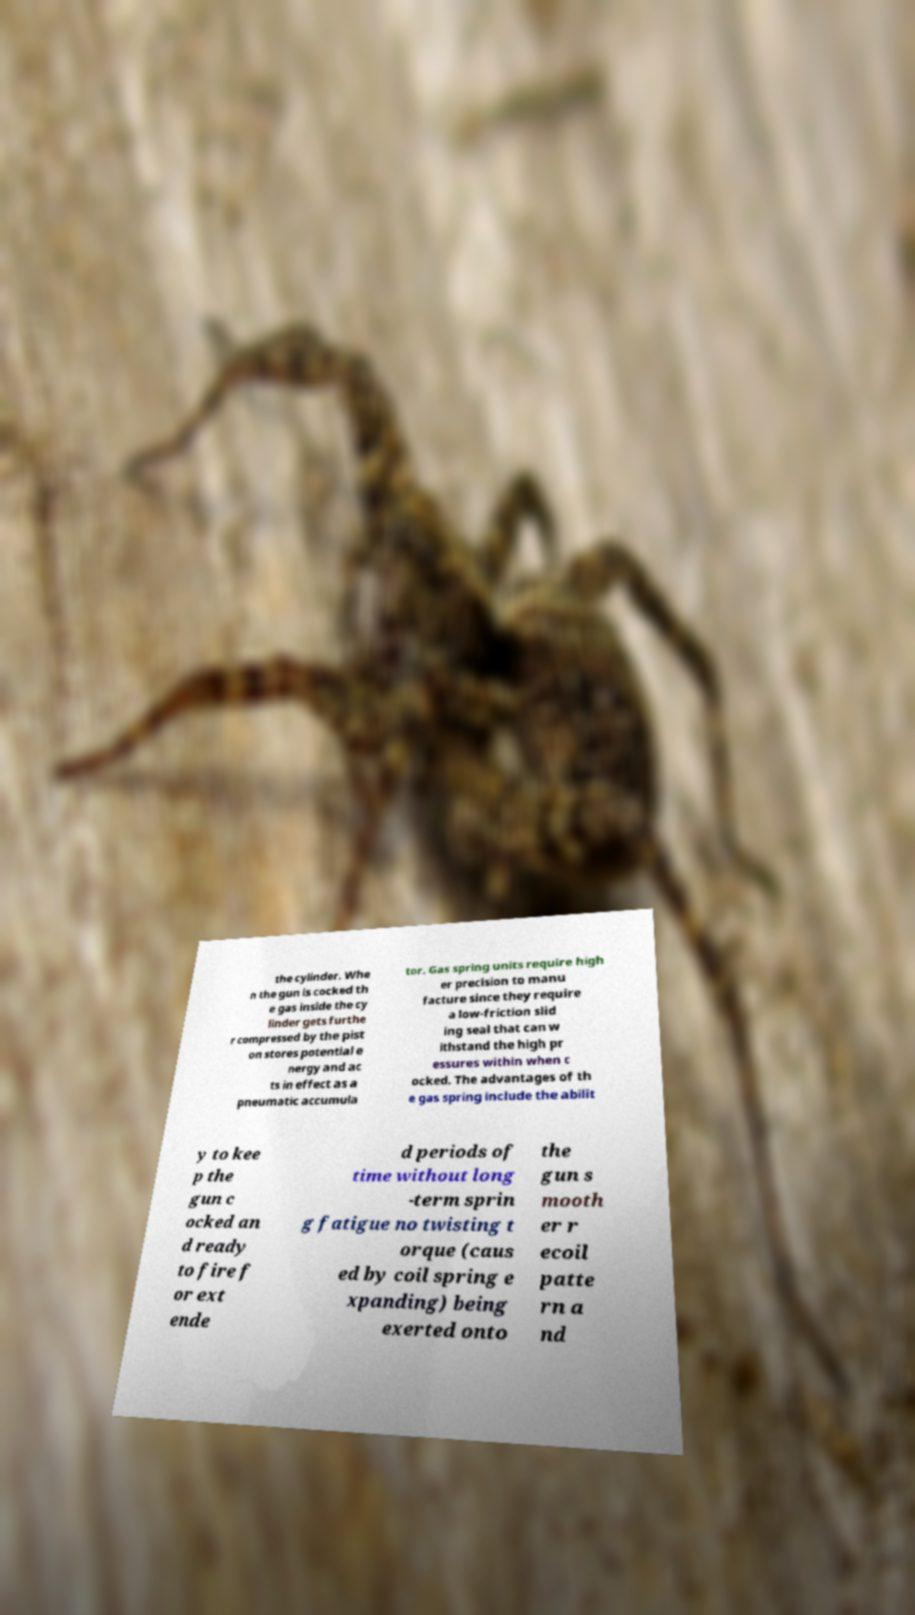Could you assist in decoding the text presented in this image and type it out clearly? the cylinder. Whe n the gun is cocked th e gas inside the cy linder gets furthe r compressed by the pist on stores potential e nergy and ac ts in effect as a pneumatic accumula tor. Gas spring units require high er precision to manu facture since they require a low-friction slid ing seal that can w ithstand the high pr essures within when c ocked. The advantages of th e gas spring include the abilit y to kee p the gun c ocked an d ready to fire f or ext ende d periods of time without long -term sprin g fatigue no twisting t orque (caus ed by coil spring e xpanding) being exerted onto the gun s mooth er r ecoil patte rn a nd 